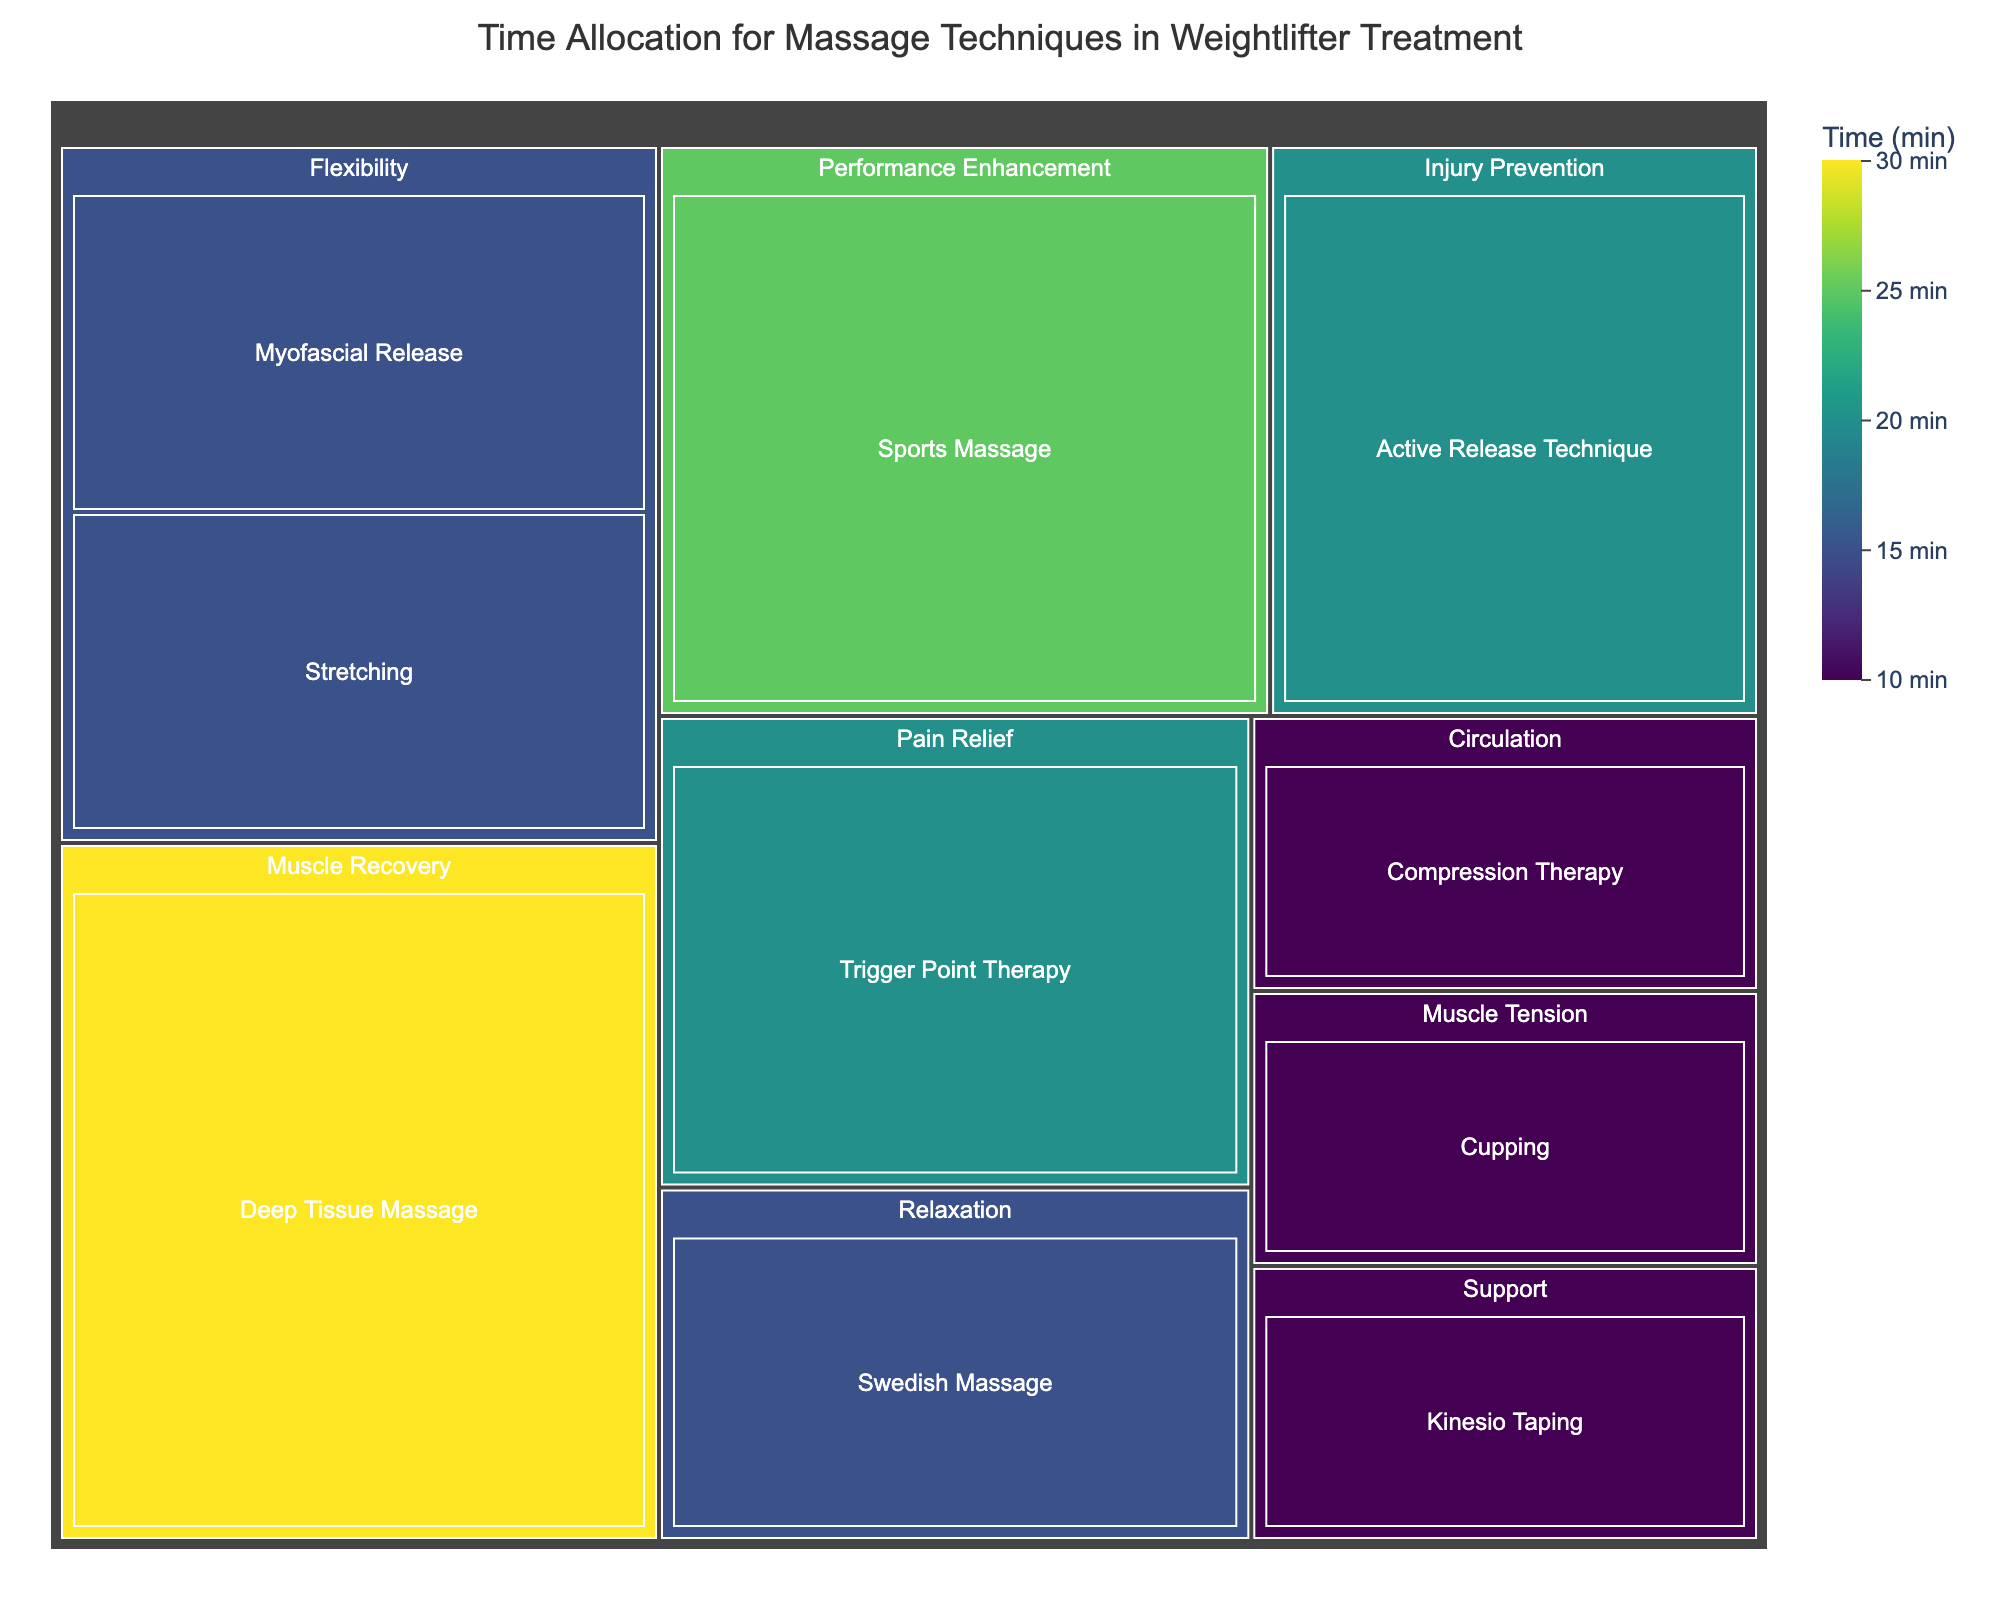What is the title of the figure? The title is located at the top of the figure and serves to summarize the content. The treemap title reads "Time Allocation for Massage Techniques in Weightlifter Treatment".
Answer: Time Allocation for Massage Techniques in Weightlifter Treatment Which massage technique has the highest allocated time? To find the technique with the highest allocated time, look for the largest box in the treemap's color gradient and hover over it. The "Deep Tissue Massage" in the "Muscle Recovery" category has the highest time of 30 minutes.
Answer: Deep Tissue Massage What are the different categories represented in the figure? Each category is represented by a different section within the treemap. The categories include Muscle Recovery, Relaxation, Pain Relief, Performance Enhancement, Flexibility, Injury Prevention, Circulation, Muscle Tension, and Support.
Answer: Muscle Recovery, Relaxation, Pain Relief, Performance Enhancement, Flexibility, Injury Prevention, Circulation, Muscle Tension, Support How much total time is allocated to techniques that improve flexibility? Add the times allocated to techniques under the "Flexibility" category. Myofascial Release is 15 minutes and Stretching is 15 minutes. The total is 15 + 15 = 30 minutes.
Answer: 30 minutes What technique has the same allocated time within the "Flexibility" and "Relaxation" categories? Look at the boxes representing the techniques in “Flexibility” and “Relaxation” categories. Both Myofascial Release and Swedish Massage are allocated 15 minutes each.
Answer: Myofascial Release and Swedish Massage Which category has more time allocated: Pain Relief or Circulation? Compare the total times of each category. Pain Relief (Trigger Point Therapy) has 20 minutes, while Circulation (Compression Therapy) has 10 minutes. Therefore, Pain Relief has more time allocated.
Answer: Pain Relief What is the total time allocated for techniques in the Pain Relief category? There is only one technique in the Pain Relief category, Trigger Point Therapy, which has 20 minutes. The total time is 20 minutes.
Answer: 20 minutes Which technique is used for injury prevention and how much time is allocated to it? Injury Prevention category contains the Active Release Technique, which has an allocated time of 20 minutes.
Answer: Active Release Technique, 20 minutes Compare the time allocated between Sports Massage and Trigger Point Therapy. Which one is higher and by how much? Sports Massage has 25 minutes and Trigger Point Therapy has 20 minutes. The difference is 25 - 20 = 5 minutes. Sports Massage has 5 minutes more allocated.
Answer: Sports Massage, 5 minutes more Given the data in the treemap, what is the average time allocated to each technique? Summing all times: 30+15+20+25+15+20+10+10+15+10 = 170 minutes. There are 10 techniques. The average time is 170 / 10 = 17 minutes.
Answer: 17 minutes 